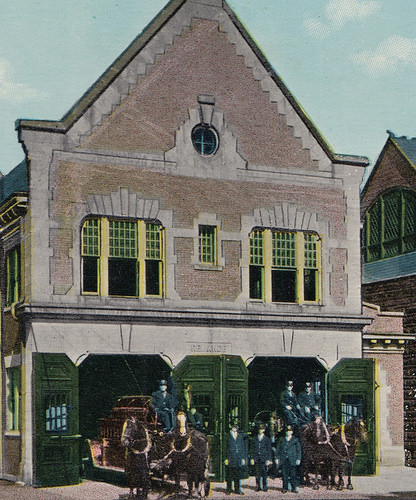<image>
Is there a horses to the right of the building? No. The horses is not to the right of the building. The horizontal positioning shows a different relationship. 